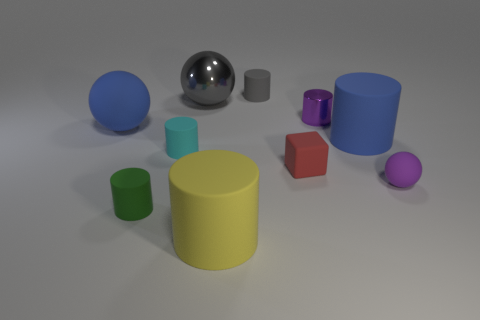Can you tell me which objects are in direct contact with the grey plane? Certainly, each object in the image is resting directly on the grey plane. There are no floating or elevated objects. The shadows provide a good indication of their contact with the plane, as you can see a shadow cast directly beneath each item. Which is the largest object, and what color is it? The largest object appears to be the yellow cylinder in the center of the composition. Its size is more substantial in both height and diameter compared to the other objects in the scene. 